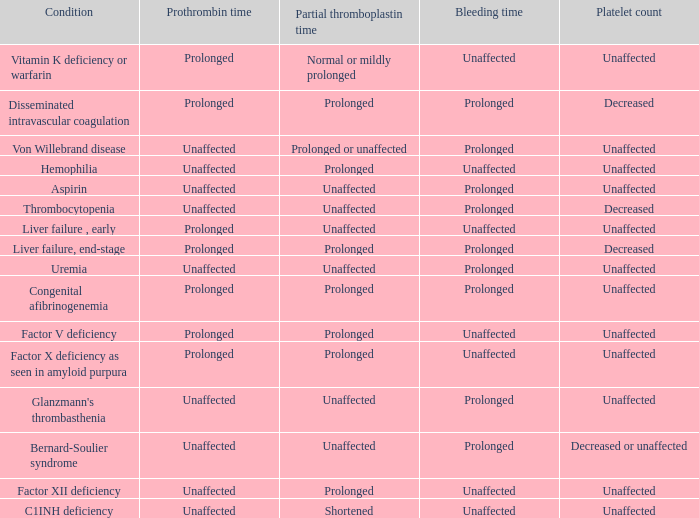During early liver failure, what partial thromboplastin time can be observed? Unaffected. 